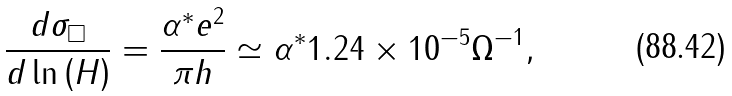Convert formula to latex. <formula><loc_0><loc_0><loc_500><loc_500>\frac { d \sigma _ { \square } } { d \ln \left ( H \right ) } = \frac { \alpha ^ { \ast } e ^ { 2 } } { \pi h } \simeq \alpha ^ { \ast } 1 . 2 4 \times 1 0 ^ { - 5 } \Omega ^ { - 1 } ,</formula> 